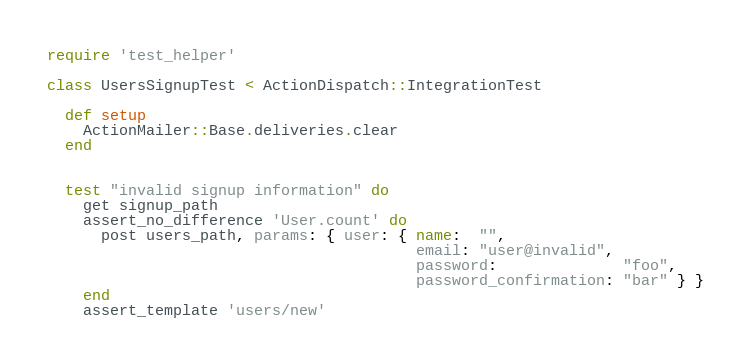Convert code to text. <code><loc_0><loc_0><loc_500><loc_500><_Ruby_>require 'test_helper'

class UsersSignupTest < ActionDispatch::IntegrationTest
  
  def setup
    ActionMailer::Base.deliveries.clear
  end

  
  test "invalid signup information" do
    get signup_path
    assert_no_difference 'User.count' do
      post users_path, params: { user: { name:  "",
                                         email: "user@invalid",
                                         password:              "foo",
                                         password_confirmation: "bar" } }
    end
    assert_template 'users/new'</code> 